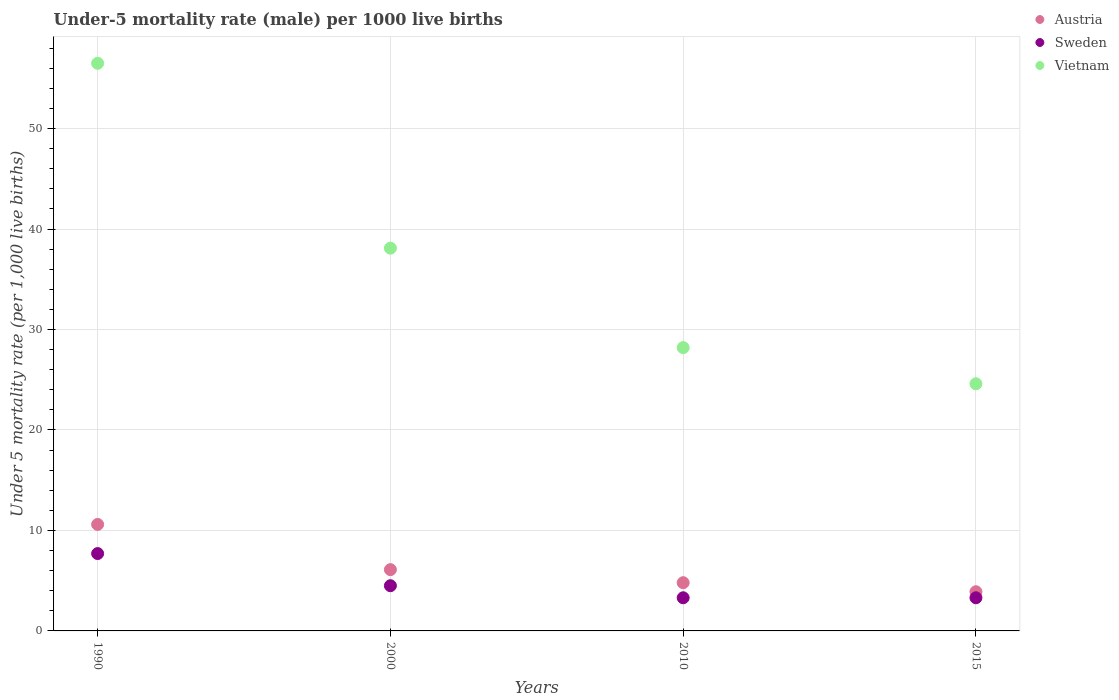How many different coloured dotlines are there?
Your answer should be very brief. 3. Is the number of dotlines equal to the number of legend labels?
Ensure brevity in your answer.  Yes. What is the under-five mortality rate in Austria in 1990?
Offer a very short reply. 10.6. Across all years, what is the maximum under-five mortality rate in Austria?
Your answer should be compact. 10.6. Across all years, what is the minimum under-five mortality rate in Sweden?
Your answer should be very brief. 3.3. In which year was the under-five mortality rate in Sweden maximum?
Provide a succinct answer. 1990. In which year was the under-five mortality rate in Austria minimum?
Ensure brevity in your answer.  2015. What is the total under-five mortality rate in Austria in the graph?
Provide a short and direct response. 25.4. What is the average under-five mortality rate in Austria per year?
Ensure brevity in your answer.  6.35. In the year 2000, what is the difference between the under-five mortality rate in Sweden and under-five mortality rate in Vietnam?
Give a very brief answer. -33.6. In how many years, is the under-five mortality rate in Vietnam greater than 54?
Offer a terse response. 1. What is the ratio of the under-five mortality rate in Austria in 2000 to that in 2010?
Offer a terse response. 1.27. What is the difference between the highest and the lowest under-five mortality rate in Vietnam?
Ensure brevity in your answer.  31.9. In how many years, is the under-five mortality rate in Vietnam greater than the average under-five mortality rate in Vietnam taken over all years?
Give a very brief answer. 2. Does the under-five mortality rate in Vietnam monotonically increase over the years?
Make the answer very short. No. Does the graph contain any zero values?
Provide a succinct answer. No. Does the graph contain grids?
Offer a very short reply. Yes. How many legend labels are there?
Offer a terse response. 3. What is the title of the graph?
Offer a terse response. Under-5 mortality rate (male) per 1000 live births. What is the label or title of the X-axis?
Keep it short and to the point. Years. What is the label or title of the Y-axis?
Provide a short and direct response. Under 5 mortality rate (per 1,0 live births). What is the Under 5 mortality rate (per 1,000 live births) in Austria in 1990?
Your response must be concise. 10.6. What is the Under 5 mortality rate (per 1,000 live births) in Sweden in 1990?
Keep it short and to the point. 7.7. What is the Under 5 mortality rate (per 1,000 live births) in Vietnam in 1990?
Keep it short and to the point. 56.5. What is the Under 5 mortality rate (per 1,000 live births) in Austria in 2000?
Your answer should be compact. 6.1. What is the Under 5 mortality rate (per 1,000 live births) of Sweden in 2000?
Make the answer very short. 4.5. What is the Under 5 mortality rate (per 1,000 live births) of Vietnam in 2000?
Make the answer very short. 38.1. What is the Under 5 mortality rate (per 1,000 live births) in Austria in 2010?
Offer a terse response. 4.8. What is the Under 5 mortality rate (per 1,000 live births) of Sweden in 2010?
Your answer should be very brief. 3.3. What is the Under 5 mortality rate (per 1,000 live births) in Vietnam in 2010?
Provide a succinct answer. 28.2. What is the Under 5 mortality rate (per 1,000 live births) in Austria in 2015?
Give a very brief answer. 3.9. What is the Under 5 mortality rate (per 1,000 live births) in Vietnam in 2015?
Keep it short and to the point. 24.6. Across all years, what is the maximum Under 5 mortality rate (per 1,000 live births) of Vietnam?
Make the answer very short. 56.5. Across all years, what is the minimum Under 5 mortality rate (per 1,000 live births) of Austria?
Provide a short and direct response. 3.9. Across all years, what is the minimum Under 5 mortality rate (per 1,000 live births) in Sweden?
Your response must be concise. 3.3. Across all years, what is the minimum Under 5 mortality rate (per 1,000 live births) in Vietnam?
Provide a short and direct response. 24.6. What is the total Under 5 mortality rate (per 1,000 live births) of Austria in the graph?
Provide a succinct answer. 25.4. What is the total Under 5 mortality rate (per 1,000 live births) in Vietnam in the graph?
Ensure brevity in your answer.  147.4. What is the difference between the Under 5 mortality rate (per 1,000 live births) in Austria in 1990 and that in 2000?
Give a very brief answer. 4.5. What is the difference between the Under 5 mortality rate (per 1,000 live births) of Austria in 1990 and that in 2010?
Provide a succinct answer. 5.8. What is the difference between the Under 5 mortality rate (per 1,000 live births) in Vietnam in 1990 and that in 2010?
Your response must be concise. 28.3. What is the difference between the Under 5 mortality rate (per 1,000 live births) of Sweden in 1990 and that in 2015?
Keep it short and to the point. 4.4. What is the difference between the Under 5 mortality rate (per 1,000 live births) of Vietnam in 1990 and that in 2015?
Provide a short and direct response. 31.9. What is the difference between the Under 5 mortality rate (per 1,000 live births) of Austria in 2000 and that in 2010?
Provide a succinct answer. 1.3. What is the difference between the Under 5 mortality rate (per 1,000 live births) of Sweden in 2000 and that in 2010?
Offer a terse response. 1.2. What is the difference between the Under 5 mortality rate (per 1,000 live births) in Austria in 2000 and that in 2015?
Keep it short and to the point. 2.2. What is the difference between the Under 5 mortality rate (per 1,000 live births) in Sweden in 2000 and that in 2015?
Your response must be concise. 1.2. What is the difference between the Under 5 mortality rate (per 1,000 live births) of Austria in 2010 and that in 2015?
Provide a short and direct response. 0.9. What is the difference between the Under 5 mortality rate (per 1,000 live births) in Austria in 1990 and the Under 5 mortality rate (per 1,000 live births) in Sweden in 2000?
Your response must be concise. 6.1. What is the difference between the Under 5 mortality rate (per 1,000 live births) in Austria in 1990 and the Under 5 mortality rate (per 1,000 live births) in Vietnam in 2000?
Keep it short and to the point. -27.5. What is the difference between the Under 5 mortality rate (per 1,000 live births) of Sweden in 1990 and the Under 5 mortality rate (per 1,000 live births) of Vietnam in 2000?
Offer a very short reply. -30.4. What is the difference between the Under 5 mortality rate (per 1,000 live births) in Austria in 1990 and the Under 5 mortality rate (per 1,000 live births) in Vietnam in 2010?
Give a very brief answer. -17.6. What is the difference between the Under 5 mortality rate (per 1,000 live births) in Sweden in 1990 and the Under 5 mortality rate (per 1,000 live births) in Vietnam in 2010?
Make the answer very short. -20.5. What is the difference between the Under 5 mortality rate (per 1,000 live births) in Austria in 1990 and the Under 5 mortality rate (per 1,000 live births) in Sweden in 2015?
Keep it short and to the point. 7.3. What is the difference between the Under 5 mortality rate (per 1,000 live births) of Sweden in 1990 and the Under 5 mortality rate (per 1,000 live births) of Vietnam in 2015?
Your answer should be very brief. -16.9. What is the difference between the Under 5 mortality rate (per 1,000 live births) of Austria in 2000 and the Under 5 mortality rate (per 1,000 live births) of Vietnam in 2010?
Give a very brief answer. -22.1. What is the difference between the Under 5 mortality rate (per 1,000 live births) in Sweden in 2000 and the Under 5 mortality rate (per 1,000 live births) in Vietnam in 2010?
Keep it short and to the point. -23.7. What is the difference between the Under 5 mortality rate (per 1,000 live births) of Austria in 2000 and the Under 5 mortality rate (per 1,000 live births) of Vietnam in 2015?
Offer a terse response. -18.5. What is the difference between the Under 5 mortality rate (per 1,000 live births) in Sweden in 2000 and the Under 5 mortality rate (per 1,000 live births) in Vietnam in 2015?
Ensure brevity in your answer.  -20.1. What is the difference between the Under 5 mortality rate (per 1,000 live births) of Austria in 2010 and the Under 5 mortality rate (per 1,000 live births) of Sweden in 2015?
Ensure brevity in your answer.  1.5. What is the difference between the Under 5 mortality rate (per 1,000 live births) of Austria in 2010 and the Under 5 mortality rate (per 1,000 live births) of Vietnam in 2015?
Provide a succinct answer. -19.8. What is the difference between the Under 5 mortality rate (per 1,000 live births) in Sweden in 2010 and the Under 5 mortality rate (per 1,000 live births) in Vietnam in 2015?
Provide a succinct answer. -21.3. What is the average Under 5 mortality rate (per 1,000 live births) of Austria per year?
Offer a very short reply. 6.35. What is the average Under 5 mortality rate (per 1,000 live births) in Sweden per year?
Make the answer very short. 4.7. What is the average Under 5 mortality rate (per 1,000 live births) of Vietnam per year?
Your response must be concise. 36.85. In the year 1990, what is the difference between the Under 5 mortality rate (per 1,000 live births) of Austria and Under 5 mortality rate (per 1,000 live births) of Vietnam?
Your response must be concise. -45.9. In the year 1990, what is the difference between the Under 5 mortality rate (per 1,000 live births) in Sweden and Under 5 mortality rate (per 1,000 live births) in Vietnam?
Offer a terse response. -48.8. In the year 2000, what is the difference between the Under 5 mortality rate (per 1,000 live births) in Austria and Under 5 mortality rate (per 1,000 live births) in Sweden?
Provide a succinct answer. 1.6. In the year 2000, what is the difference between the Under 5 mortality rate (per 1,000 live births) in Austria and Under 5 mortality rate (per 1,000 live births) in Vietnam?
Your response must be concise. -32. In the year 2000, what is the difference between the Under 5 mortality rate (per 1,000 live births) of Sweden and Under 5 mortality rate (per 1,000 live births) of Vietnam?
Your answer should be very brief. -33.6. In the year 2010, what is the difference between the Under 5 mortality rate (per 1,000 live births) of Austria and Under 5 mortality rate (per 1,000 live births) of Vietnam?
Your answer should be compact. -23.4. In the year 2010, what is the difference between the Under 5 mortality rate (per 1,000 live births) in Sweden and Under 5 mortality rate (per 1,000 live births) in Vietnam?
Your response must be concise. -24.9. In the year 2015, what is the difference between the Under 5 mortality rate (per 1,000 live births) of Austria and Under 5 mortality rate (per 1,000 live births) of Vietnam?
Your response must be concise. -20.7. In the year 2015, what is the difference between the Under 5 mortality rate (per 1,000 live births) in Sweden and Under 5 mortality rate (per 1,000 live births) in Vietnam?
Your answer should be compact. -21.3. What is the ratio of the Under 5 mortality rate (per 1,000 live births) in Austria in 1990 to that in 2000?
Ensure brevity in your answer.  1.74. What is the ratio of the Under 5 mortality rate (per 1,000 live births) of Sweden in 1990 to that in 2000?
Your answer should be compact. 1.71. What is the ratio of the Under 5 mortality rate (per 1,000 live births) of Vietnam in 1990 to that in 2000?
Give a very brief answer. 1.48. What is the ratio of the Under 5 mortality rate (per 1,000 live births) of Austria in 1990 to that in 2010?
Your answer should be very brief. 2.21. What is the ratio of the Under 5 mortality rate (per 1,000 live births) of Sweden in 1990 to that in 2010?
Your answer should be very brief. 2.33. What is the ratio of the Under 5 mortality rate (per 1,000 live births) in Vietnam in 1990 to that in 2010?
Make the answer very short. 2. What is the ratio of the Under 5 mortality rate (per 1,000 live births) of Austria in 1990 to that in 2015?
Give a very brief answer. 2.72. What is the ratio of the Under 5 mortality rate (per 1,000 live births) of Sweden in 1990 to that in 2015?
Your answer should be very brief. 2.33. What is the ratio of the Under 5 mortality rate (per 1,000 live births) of Vietnam in 1990 to that in 2015?
Your response must be concise. 2.3. What is the ratio of the Under 5 mortality rate (per 1,000 live births) in Austria in 2000 to that in 2010?
Give a very brief answer. 1.27. What is the ratio of the Under 5 mortality rate (per 1,000 live births) in Sweden in 2000 to that in 2010?
Provide a short and direct response. 1.36. What is the ratio of the Under 5 mortality rate (per 1,000 live births) in Vietnam in 2000 to that in 2010?
Your answer should be compact. 1.35. What is the ratio of the Under 5 mortality rate (per 1,000 live births) in Austria in 2000 to that in 2015?
Make the answer very short. 1.56. What is the ratio of the Under 5 mortality rate (per 1,000 live births) in Sweden in 2000 to that in 2015?
Give a very brief answer. 1.36. What is the ratio of the Under 5 mortality rate (per 1,000 live births) in Vietnam in 2000 to that in 2015?
Give a very brief answer. 1.55. What is the ratio of the Under 5 mortality rate (per 1,000 live births) of Austria in 2010 to that in 2015?
Ensure brevity in your answer.  1.23. What is the ratio of the Under 5 mortality rate (per 1,000 live births) in Sweden in 2010 to that in 2015?
Your answer should be very brief. 1. What is the ratio of the Under 5 mortality rate (per 1,000 live births) of Vietnam in 2010 to that in 2015?
Offer a terse response. 1.15. What is the difference between the highest and the second highest Under 5 mortality rate (per 1,000 live births) in Austria?
Offer a terse response. 4.5. What is the difference between the highest and the second highest Under 5 mortality rate (per 1,000 live births) of Sweden?
Keep it short and to the point. 3.2. What is the difference between the highest and the lowest Under 5 mortality rate (per 1,000 live births) of Sweden?
Make the answer very short. 4.4. What is the difference between the highest and the lowest Under 5 mortality rate (per 1,000 live births) of Vietnam?
Offer a terse response. 31.9. 